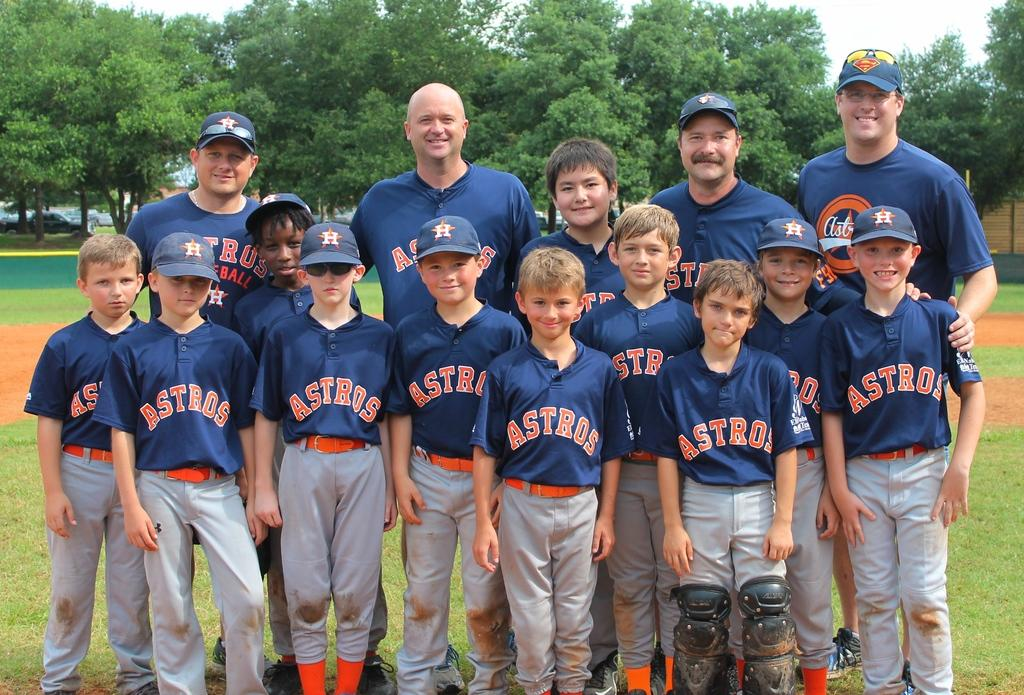<image>
Offer a succinct explanation of the picture presented. some players are lined up for a photo wearing Astros jerseys 